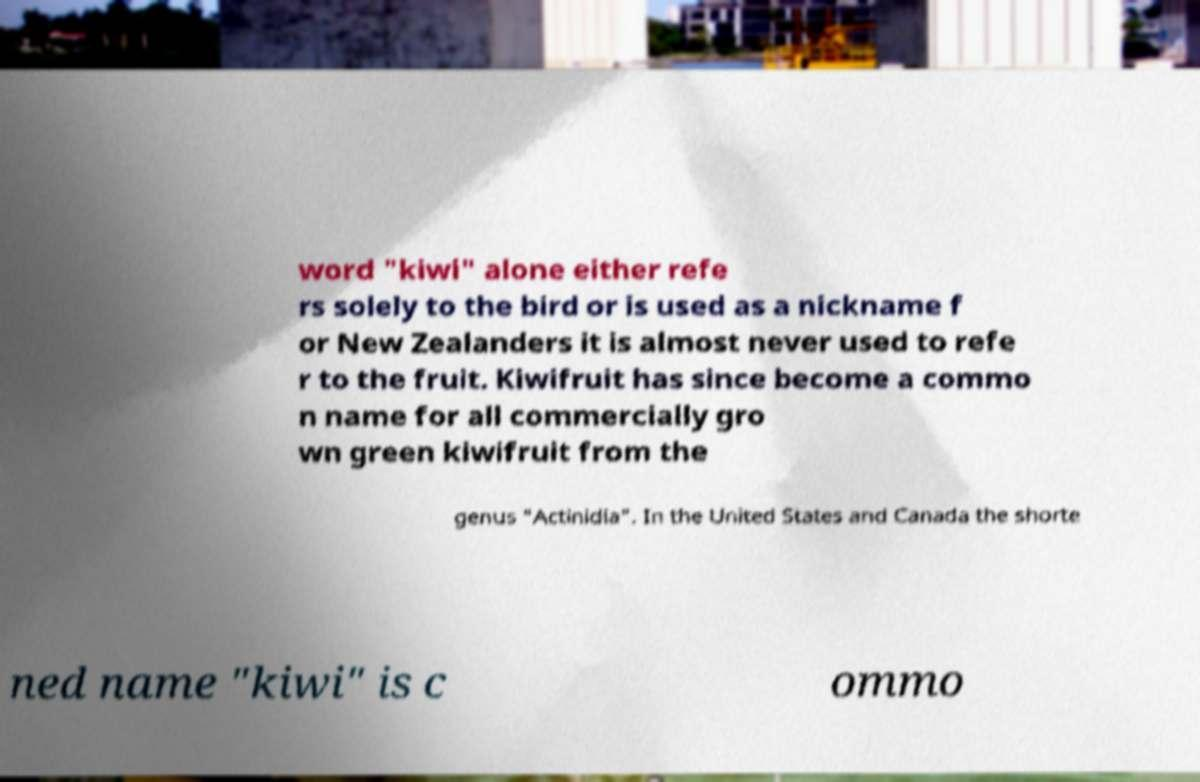I need the written content from this picture converted into text. Can you do that? word "kiwi" alone either refe rs solely to the bird or is used as a nickname f or New Zealanders it is almost never used to refe r to the fruit. Kiwifruit has since become a commo n name for all commercially gro wn green kiwifruit from the genus "Actinidia". In the United States and Canada the shorte ned name "kiwi" is c ommo 